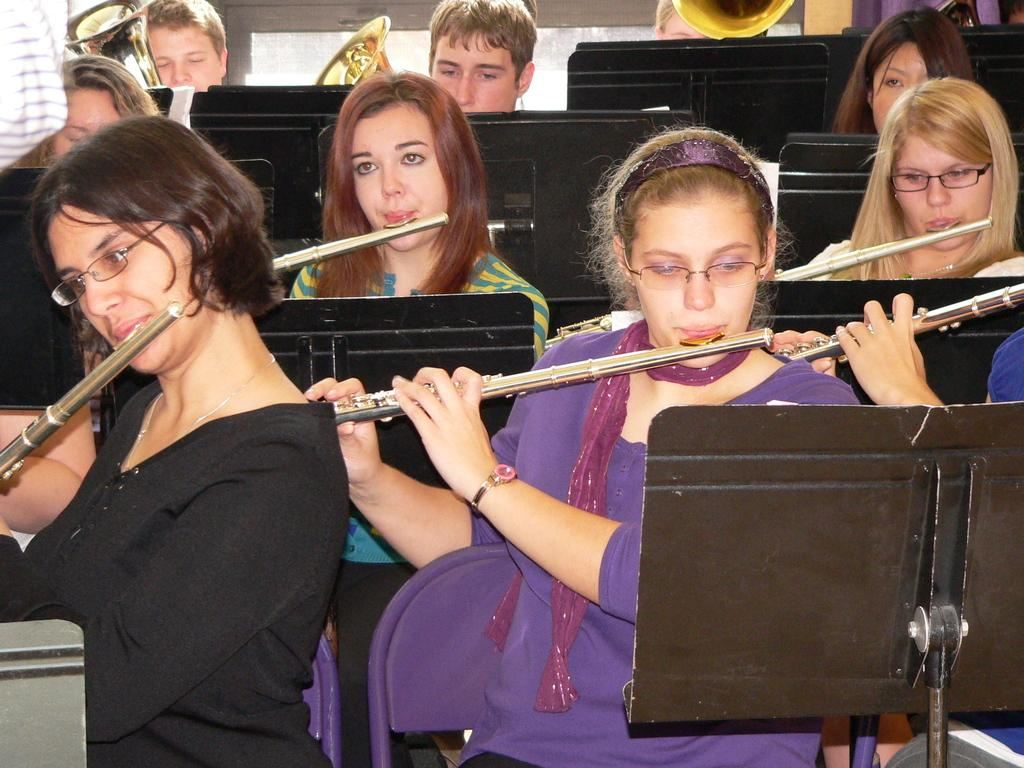What are the people in the image doing? The people in the image are sitting and playing musical instruments. What objects are in front of the people? There are book holders with stands in front of the people. What are the people holding while they are sitting? The people are holding musical instruments. What type of group is visible in the image? There is no specific group mentioned or visible in the image. What things can be seen on the table in the image? The provided facts do not mention any table or things on a table in the image. 